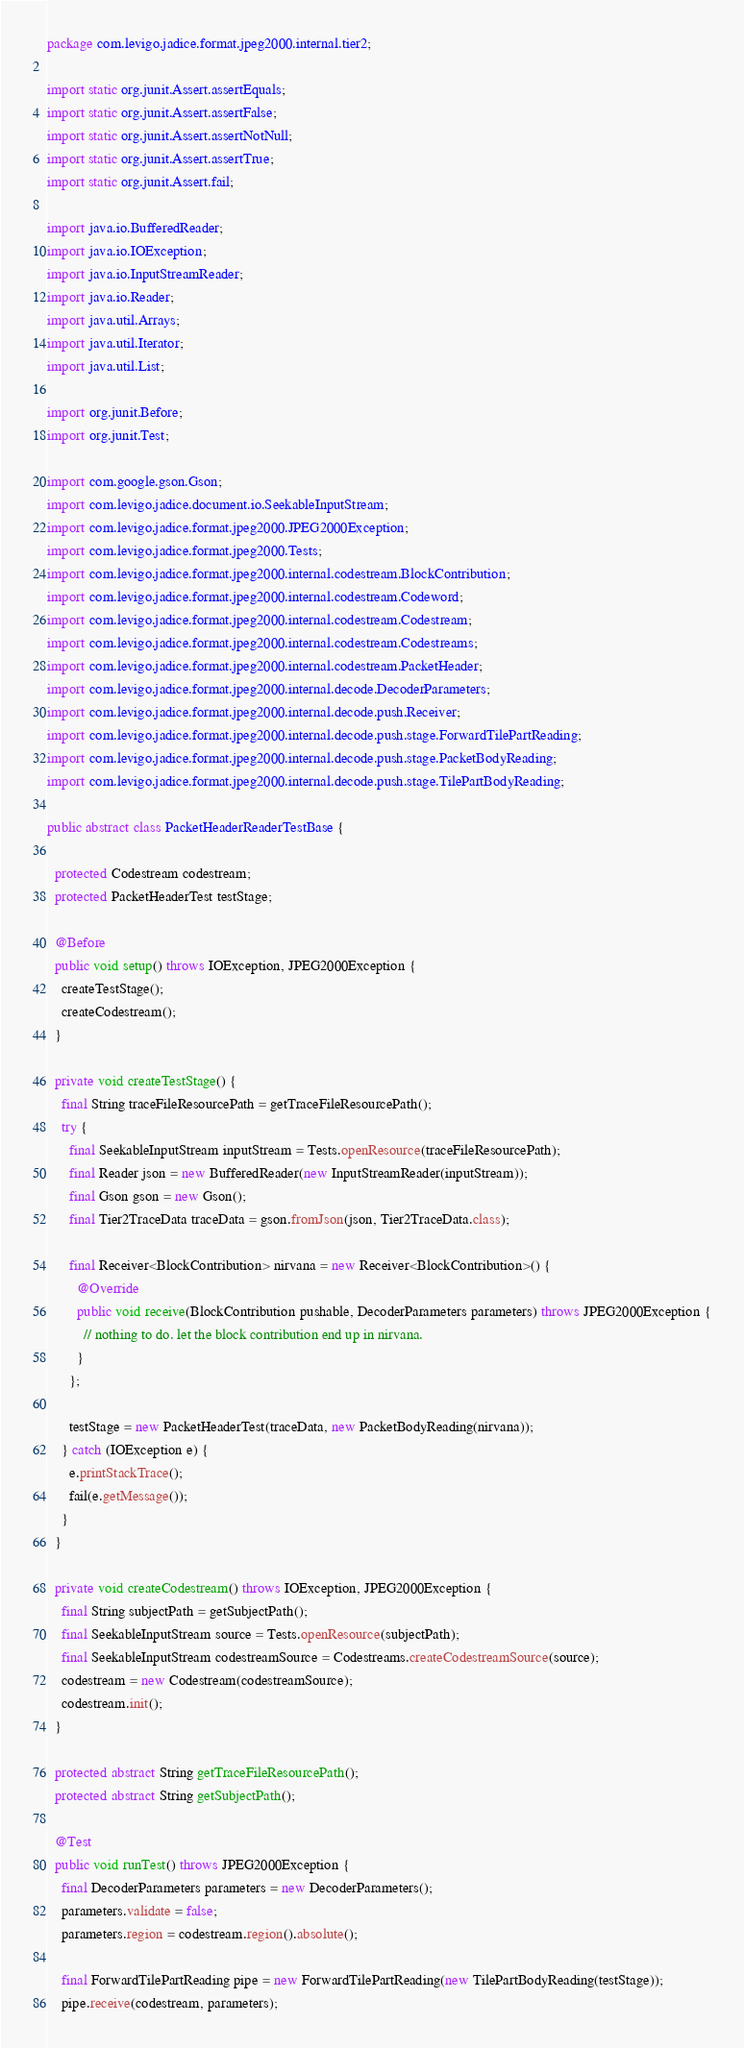Convert code to text. <code><loc_0><loc_0><loc_500><loc_500><_Java_>package com.levigo.jadice.format.jpeg2000.internal.tier2;

import static org.junit.Assert.assertEquals;
import static org.junit.Assert.assertFalse;
import static org.junit.Assert.assertNotNull;
import static org.junit.Assert.assertTrue;
import static org.junit.Assert.fail;

import java.io.BufferedReader;
import java.io.IOException;
import java.io.InputStreamReader;
import java.io.Reader;
import java.util.Arrays;
import java.util.Iterator;
import java.util.List;

import org.junit.Before;
import org.junit.Test;

import com.google.gson.Gson;
import com.levigo.jadice.document.io.SeekableInputStream;
import com.levigo.jadice.format.jpeg2000.JPEG2000Exception;
import com.levigo.jadice.format.jpeg2000.Tests;
import com.levigo.jadice.format.jpeg2000.internal.codestream.BlockContribution;
import com.levigo.jadice.format.jpeg2000.internal.codestream.Codeword;
import com.levigo.jadice.format.jpeg2000.internal.codestream.Codestream;
import com.levigo.jadice.format.jpeg2000.internal.codestream.Codestreams;
import com.levigo.jadice.format.jpeg2000.internal.codestream.PacketHeader;
import com.levigo.jadice.format.jpeg2000.internal.decode.DecoderParameters;
import com.levigo.jadice.format.jpeg2000.internal.decode.push.Receiver;
import com.levigo.jadice.format.jpeg2000.internal.decode.push.stage.ForwardTilePartReading;
import com.levigo.jadice.format.jpeg2000.internal.decode.push.stage.PacketBodyReading;
import com.levigo.jadice.format.jpeg2000.internal.decode.push.stage.TilePartBodyReading;

public abstract class PacketHeaderReaderTestBase {

  protected Codestream codestream;
  protected PacketHeaderTest testStage;

  @Before
  public void setup() throws IOException, JPEG2000Exception {
    createTestStage();
    createCodestream();
  }

  private void createTestStage() {
    final String traceFileResourcePath = getTraceFileResourcePath();
    try {
      final SeekableInputStream inputStream = Tests.openResource(traceFileResourcePath);
      final Reader json = new BufferedReader(new InputStreamReader(inputStream));
      final Gson gson = new Gson();
      final Tier2TraceData traceData = gson.fromJson(json, Tier2TraceData.class);

      final Receiver<BlockContribution> nirvana = new Receiver<BlockContribution>() {
        @Override
        public void receive(BlockContribution pushable, DecoderParameters parameters) throws JPEG2000Exception {
          // nothing to do. let the block contribution end up in nirvana.
        }
      };

      testStage = new PacketHeaderTest(traceData, new PacketBodyReading(nirvana));
    } catch (IOException e) {
      e.printStackTrace();
      fail(e.getMessage());
    }
  }

  private void createCodestream() throws IOException, JPEG2000Exception {
    final String subjectPath = getSubjectPath();
    final SeekableInputStream source = Tests.openResource(subjectPath);
    final SeekableInputStream codestreamSource = Codestreams.createCodestreamSource(source);
    codestream = new Codestream(codestreamSource);
    codestream.init();
  }

  protected abstract String getTraceFileResourcePath();
  protected abstract String getSubjectPath();

  @Test
  public void runTest() throws JPEG2000Exception {
    final DecoderParameters parameters = new DecoderParameters();
    parameters.validate = false;
    parameters.region = codestream.region().absolute();

    final ForwardTilePartReading pipe = new ForwardTilePartReading(new TilePartBodyReading(testStage));
    pipe.receive(codestream, parameters);</code> 